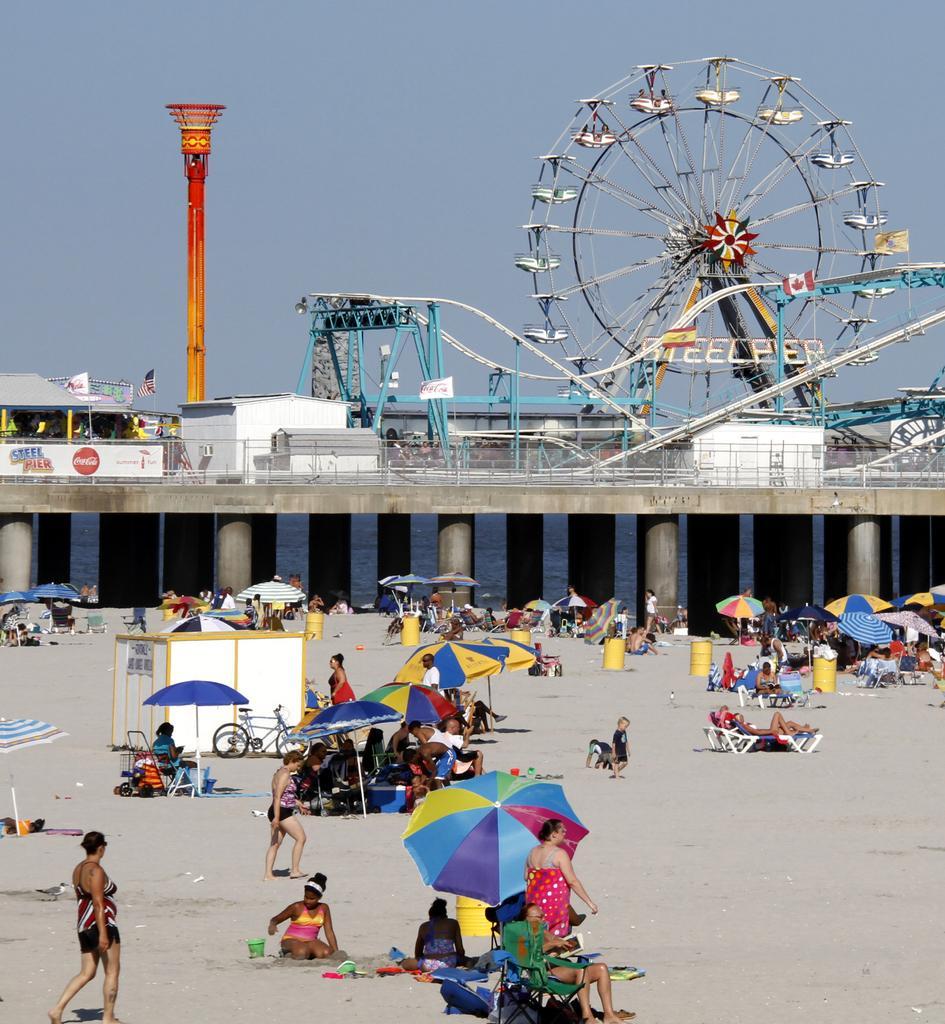Please provide a concise description of this image. In this image I see number of people over here and I see number of umbrellas which are colorful. In the background I see the amusement parks rides and I see the sky and I see a cycle over here. 